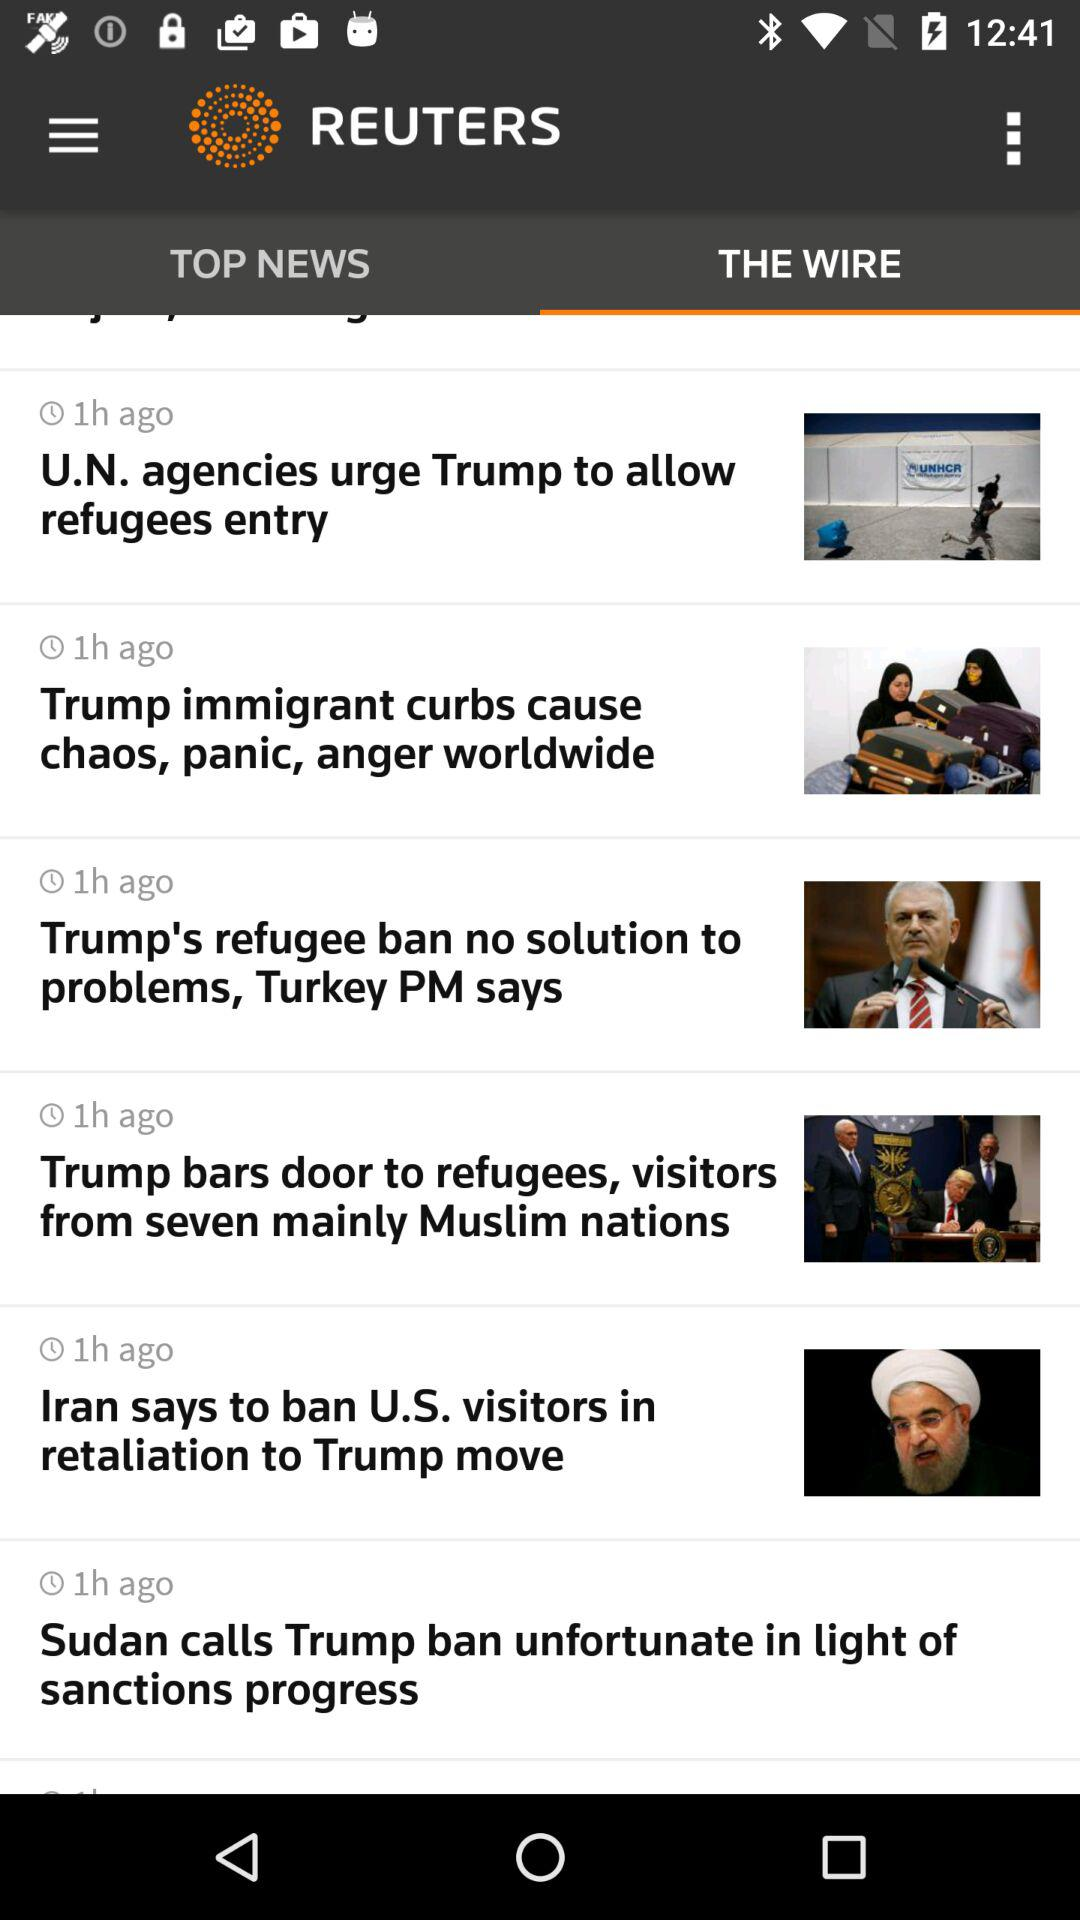How many news items are there?
Answer the question using a single word or phrase. 6 